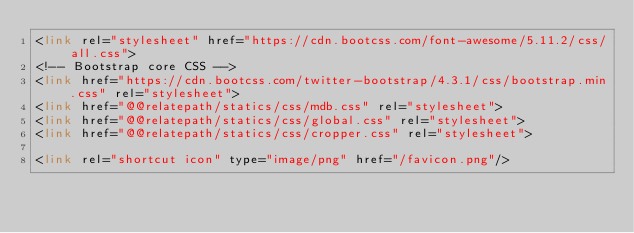Convert code to text. <code><loc_0><loc_0><loc_500><loc_500><_HTML_><link rel="stylesheet" href="https://cdn.bootcss.com/font-awesome/5.11.2/css/all.css">
<!-- Bootstrap core CSS -->
<link href="https://cdn.bootcss.com/twitter-bootstrap/4.3.1/css/bootstrap.min.css" rel="stylesheet">
<link href="@@relatepath/statics/css/mdb.css" rel="stylesheet">
<link href="@@relatepath/statics/css/global.css" rel="stylesheet">
<link href="@@relatepath/statics/css/cropper.css" rel="stylesheet">

<link rel="shortcut icon" type="image/png" href="/favicon.png"/>


</code> 